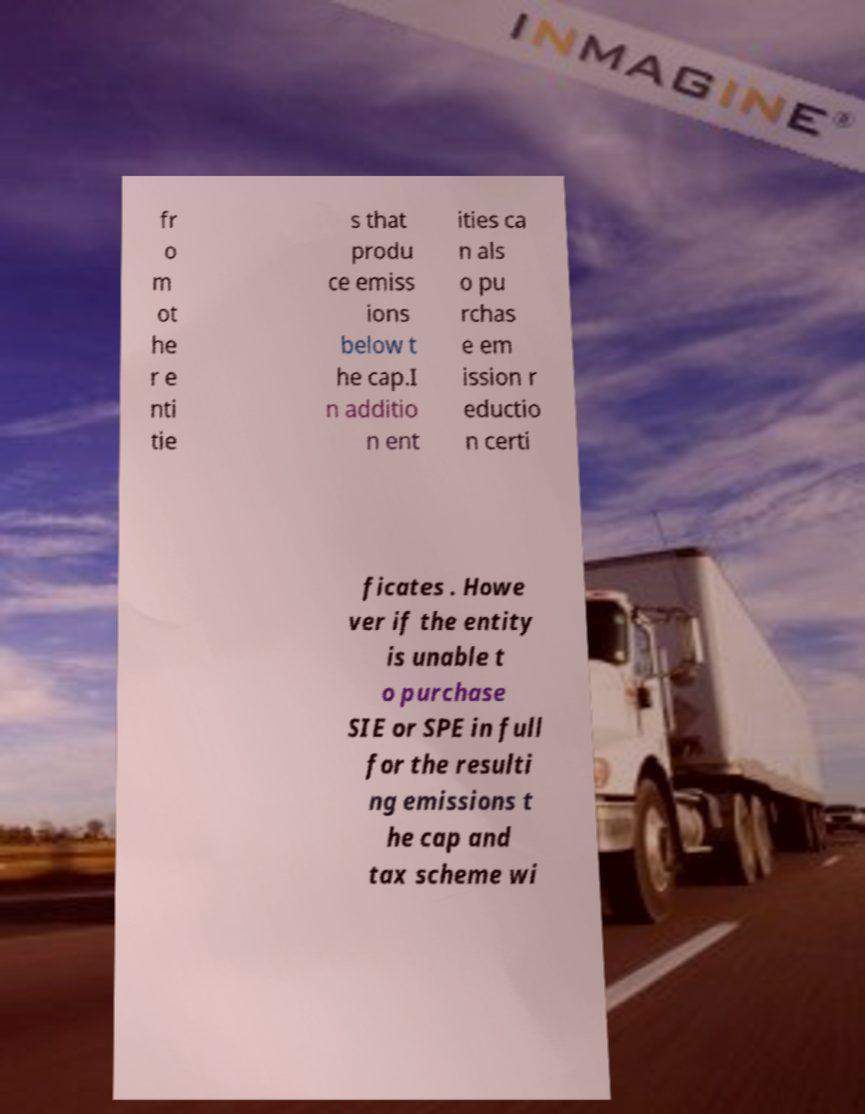I need the written content from this picture converted into text. Can you do that? fr o m ot he r e nti tie s that produ ce emiss ions below t he cap.I n additio n ent ities ca n als o pu rchas e em ission r eductio n certi ficates . Howe ver if the entity is unable t o purchase SIE or SPE in full for the resulti ng emissions t he cap and tax scheme wi 